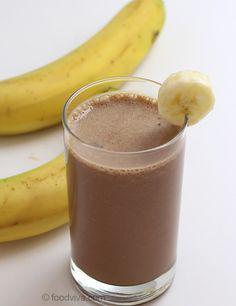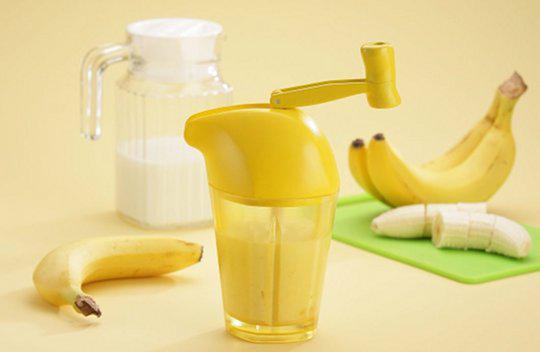The first image is the image on the left, the second image is the image on the right. Considering the images on both sides, is "there is a glass with at least one straw in it" valid? Answer yes or no. No. The first image is the image on the left, the second image is the image on the right. Analyze the images presented: Is the assertion "All images include unpeeled bananas, and one image includes a brown drink garnished with a slice of banana, while the other image includes a glass with something bright yellow sticking out of the top." valid? Answer yes or no. Yes. 